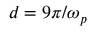<formula> <loc_0><loc_0><loc_500><loc_500>d = 9 \pi / \omega _ { p }</formula> 